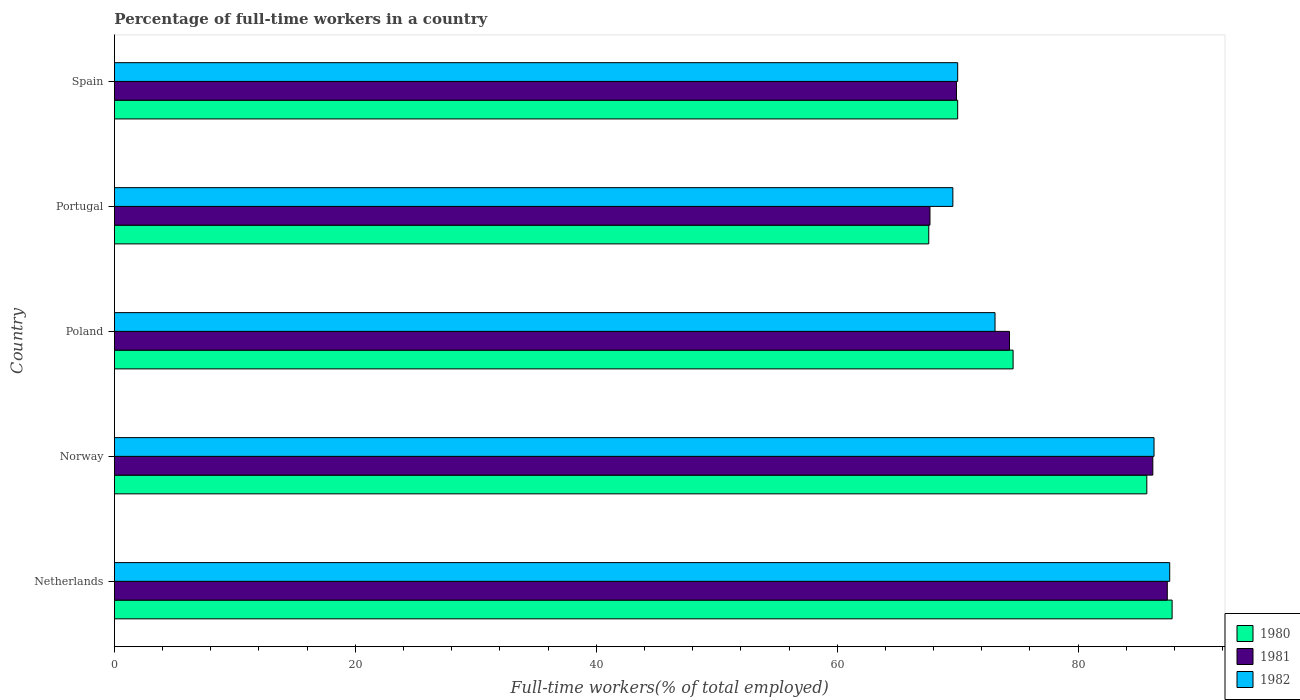Are the number of bars per tick equal to the number of legend labels?
Your answer should be very brief. Yes. Are the number of bars on each tick of the Y-axis equal?
Your answer should be compact. Yes. How many bars are there on the 3rd tick from the top?
Give a very brief answer. 3. What is the percentage of full-time workers in 1981 in Norway?
Make the answer very short. 86.2. Across all countries, what is the maximum percentage of full-time workers in 1981?
Your answer should be very brief. 87.4. Across all countries, what is the minimum percentage of full-time workers in 1980?
Your answer should be compact. 67.6. In which country was the percentage of full-time workers in 1982 maximum?
Provide a short and direct response. Netherlands. What is the total percentage of full-time workers in 1982 in the graph?
Your response must be concise. 386.6. What is the difference between the percentage of full-time workers in 1980 in Norway and that in Spain?
Provide a succinct answer. 15.7. What is the difference between the percentage of full-time workers in 1980 in Spain and the percentage of full-time workers in 1981 in Netherlands?
Keep it short and to the point. -17.4. What is the average percentage of full-time workers in 1980 per country?
Ensure brevity in your answer.  77.14. What is the difference between the percentage of full-time workers in 1981 and percentage of full-time workers in 1982 in Netherlands?
Ensure brevity in your answer.  -0.2. What is the ratio of the percentage of full-time workers in 1981 in Norway to that in Portugal?
Your answer should be very brief. 1.27. What is the difference between the highest and the second highest percentage of full-time workers in 1981?
Ensure brevity in your answer.  1.2. What is the difference between the highest and the lowest percentage of full-time workers in 1981?
Provide a succinct answer. 19.7. Is the sum of the percentage of full-time workers in 1982 in Norway and Portugal greater than the maximum percentage of full-time workers in 1981 across all countries?
Your answer should be very brief. Yes. How many bars are there?
Your answer should be compact. 15. Are all the bars in the graph horizontal?
Your answer should be very brief. Yes. Does the graph contain any zero values?
Offer a terse response. No. What is the title of the graph?
Keep it short and to the point. Percentage of full-time workers in a country. What is the label or title of the X-axis?
Your response must be concise. Full-time workers(% of total employed). What is the label or title of the Y-axis?
Ensure brevity in your answer.  Country. What is the Full-time workers(% of total employed) of 1980 in Netherlands?
Ensure brevity in your answer.  87.8. What is the Full-time workers(% of total employed) of 1981 in Netherlands?
Keep it short and to the point. 87.4. What is the Full-time workers(% of total employed) of 1982 in Netherlands?
Give a very brief answer. 87.6. What is the Full-time workers(% of total employed) of 1980 in Norway?
Keep it short and to the point. 85.7. What is the Full-time workers(% of total employed) in 1981 in Norway?
Provide a short and direct response. 86.2. What is the Full-time workers(% of total employed) in 1982 in Norway?
Your answer should be very brief. 86.3. What is the Full-time workers(% of total employed) in 1980 in Poland?
Your response must be concise. 74.6. What is the Full-time workers(% of total employed) of 1981 in Poland?
Provide a succinct answer. 74.3. What is the Full-time workers(% of total employed) in 1982 in Poland?
Provide a short and direct response. 73.1. What is the Full-time workers(% of total employed) of 1980 in Portugal?
Your answer should be very brief. 67.6. What is the Full-time workers(% of total employed) in 1981 in Portugal?
Your answer should be very brief. 67.7. What is the Full-time workers(% of total employed) of 1982 in Portugal?
Give a very brief answer. 69.6. What is the Full-time workers(% of total employed) of 1980 in Spain?
Ensure brevity in your answer.  70. What is the Full-time workers(% of total employed) in 1981 in Spain?
Provide a short and direct response. 69.9. Across all countries, what is the maximum Full-time workers(% of total employed) in 1980?
Provide a succinct answer. 87.8. Across all countries, what is the maximum Full-time workers(% of total employed) in 1981?
Your answer should be compact. 87.4. Across all countries, what is the maximum Full-time workers(% of total employed) of 1982?
Offer a very short reply. 87.6. Across all countries, what is the minimum Full-time workers(% of total employed) of 1980?
Your response must be concise. 67.6. Across all countries, what is the minimum Full-time workers(% of total employed) of 1981?
Ensure brevity in your answer.  67.7. Across all countries, what is the minimum Full-time workers(% of total employed) of 1982?
Offer a very short reply. 69.6. What is the total Full-time workers(% of total employed) of 1980 in the graph?
Make the answer very short. 385.7. What is the total Full-time workers(% of total employed) in 1981 in the graph?
Give a very brief answer. 385.5. What is the total Full-time workers(% of total employed) in 1982 in the graph?
Your answer should be compact. 386.6. What is the difference between the Full-time workers(% of total employed) of 1980 in Netherlands and that in Poland?
Make the answer very short. 13.2. What is the difference between the Full-time workers(% of total employed) of 1982 in Netherlands and that in Poland?
Your answer should be compact. 14.5. What is the difference between the Full-time workers(% of total employed) in 1980 in Netherlands and that in Portugal?
Ensure brevity in your answer.  20.2. What is the difference between the Full-time workers(% of total employed) in 1982 in Netherlands and that in Portugal?
Your answer should be compact. 18. What is the difference between the Full-time workers(% of total employed) in 1980 in Netherlands and that in Spain?
Give a very brief answer. 17.8. What is the difference between the Full-time workers(% of total employed) of 1981 in Netherlands and that in Spain?
Offer a terse response. 17.5. What is the difference between the Full-time workers(% of total employed) of 1982 in Netherlands and that in Spain?
Offer a terse response. 17.6. What is the difference between the Full-time workers(% of total employed) in 1980 in Norway and that in Poland?
Offer a terse response. 11.1. What is the difference between the Full-time workers(% of total employed) of 1980 in Norway and that in Portugal?
Ensure brevity in your answer.  18.1. What is the difference between the Full-time workers(% of total employed) in 1981 in Norway and that in Portugal?
Your answer should be very brief. 18.5. What is the difference between the Full-time workers(% of total employed) of 1982 in Norway and that in Portugal?
Ensure brevity in your answer.  16.7. What is the difference between the Full-time workers(% of total employed) in 1980 in Norway and that in Spain?
Ensure brevity in your answer.  15.7. What is the difference between the Full-time workers(% of total employed) of 1981 in Norway and that in Spain?
Your response must be concise. 16.3. What is the difference between the Full-time workers(% of total employed) in 1982 in Norway and that in Spain?
Your answer should be compact. 16.3. What is the difference between the Full-time workers(% of total employed) in 1982 in Poland and that in Portugal?
Your response must be concise. 3.5. What is the difference between the Full-time workers(% of total employed) of 1981 in Poland and that in Spain?
Ensure brevity in your answer.  4.4. What is the difference between the Full-time workers(% of total employed) of 1982 in Poland and that in Spain?
Your answer should be compact. 3.1. What is the difference between the Full-time workers(% of total employed) in 1980 in Portugal and that in Spain?
Provide a short and direct response. -2.4. What is the difference between the Full-time workers(% of total employed) in 1981 in Portugal and that in Spain?
Keep it short and to the point. -2.2. What is the difference between the Full-time workers(% of total employed) in 1982 in Portugal and that in Spain?
Give a very brief answer. -0.4. What is the difference between the Full-time workers(% of total employed) of 1980 in Netherlands and the Full-time workers(% of total employed) of 1981 in Norway?
Ensure brevity in your answer.  1.6. What is the difference between the Full-time workers(% of total employed) of 1981 in Netherlands and the Full-time workers(% of total employed) of 1982 in Norway?
Ensure brevity in your answer.  1.1. What is the difference between the Full-time workers(% of total employed) of 1980 in Netherlands and the Full-time workers(% of total employed) of 1981 in Poland?
Provide a succinct answer. 13.5. What is the difference between the Full-time workers(% of total employed) of 1980 in Netherlands and the Full-time workers(% of total employed) of 1982 in Poland?
Keep it short and to the point. 14.7. What is the difference between the Full-time workers(% of total employed) of 1981 in Netherlands and the Full-time workers(% of total employed) of 1982 in Poland?
Your answer should be very brief. 14.3. What is the difference between the Full-time workers(% of total employed) in 1980 in Netherlands and the Full-time workers(% of total employed) in 1981 in Portugal?
Offer a terse response. 20.1. What is the difference between the Full-time workers(% of total employed) in 1980 in Netherlands and the Full-time workers(% of total employed) in 1982 in Portugal?
Your answer should be very brief. 18.2. What is the difference between the Full-time workers(% of total employed) of 1980 in Netherlands and the Full-time workers(% of total employed) of 1982 in Spain?
Keep it short and to the point. 17.8. What is the difference between the Full-time workers(% of total employed) of 1981 in Netherlands and the Full-time workers(% of total employed) of 1982 in Spain?
Your response must be concise. 17.4. What is the difference between the Full-time workers(% of total employed) in 1980 in Norway and the Full-time workers(% of total employed) in 1981 in Poland?
Provide a short and direct response. 11.4. What is the difference between the Full-time workers(% of total employed) in 1980 in Norway and the Full-time workers(% of total employed) in 1982 in Poland?
Make the answer very short. 12.6. What is the difference between the Full-time workers(% of total employed) of 1981 in Norway and the Full-time workers(% of total employed) of 1982 in Poland?
Offer a terse response. 13.1. What is the difference between the Full-time workers(% of total employed) of 1980 in Norway and the Full-time workers(% of total employed) of 1981 in Portugal?
Offer a terse response. 18. What is the difference between the Full-time workers(% of total employed) of 1980 in Norway and the Full-time workers(% of total employed) of 1981 in Spain?
Give a very brief answer. 15.8. What is the difference between the Full-time workers(% of total employed) in 1980 in Norway and the Full-time workers(% of total employed) in 1982 in Spain?
Provide a succinct answer. 15.7. What is the difference between the Full-time workers(% of total employed) of 1980 in Poland and the Full-time workers(% of total employed) of 1982 in Portugal?
Provide a succinct answer. 5. What is the difference between the Full-time workers(% of total employed) of 1980 in Poland and the Full-time workers(% of total employed) of 1982 in Spain?
Your answer should be very brief. 4.6. What is the difference between the Full-time workers(% of total employed) of 1981 in Poland and the Full-time workers(% of total employed) of 1982 in Spain?
Offer a very short reply. 4.3. What is the difference between the Full-time workers(% of total employed) in 1981 in Portugal and the Full-time workers(% of total employed) in 1982 in Spain?
Make the answer very short. -2.3. What is the average Full-time workers(% of total employed) of 1980 per country?
Offer a terse response. 77.14. What is the average Full-time workers(% of total employed) of 1981 per country?
Your response must be concise. 77.1. What is the average Full-time workers(% of total employed) in 1982 per country?
Give a very brief answer. 77.32. What is the difference between the Full-time workers(% of total employed) of 1980 and Full-time workers(% of total employed) of 1982 in Netherlands?
Keep it short and to the point. 0.2. What is the difference between the Full-time workers(% of total employed) of 1981 and Full-time workers(% of total employed) of 1982 in Poland?
Give a very brief answer. 1.2. What is the difference between the Full-time workers(% of total employed) in 1980 and Full-time workers(% of total employed) in 1981 in Portugal?
Give a very brief answer. -0.1. What is the difference between the Full-time workers(% of total employed) of 1980 and Full-time workers(% of total employed) of 1982 in Portugal?
Provide a succinct answer. -2. What is the difference between the Full-time workers(% of total employed) in 1980 and Full-time workers(% of total employed) in 1982 in Spain?
Provide a short and direct response. 0. What is the ratio of the Full-time workers(% of total employed) of 1980 in Netherlands to that in Norway?
Your answer should be compact. 1.02. What is the ratio of the Full-time workers(% of total employed) of 1981 in Netherlands to that in Norway?
Make the answer very short. 1.01. What is the ratio of the Full-time workers(% of total employed) of 1982 in Netherlands to that in Norway?
Your answer should be very brief. 1.02. What is the ratio of the Full-time workers(% of total employed) of 1980 in Netherlands to that in Poland?
Provide a succinct answer. 1.18. What is the ratio of the Full-time workers(% of total employed) of 1981 in Netherlands to that in Poland?
Your response must be concise. 1.18. What is the ratio of the Full-time workers(% of total employed) in 1982 in Netherlands to that in Poland?
Keep it short and to the point. 1.2. What is the ratio of the Full-time workers(% of total employed) in 1980 in Netherlands to that in Portugal?
Keep it short and to the point. 1.3. What is the ratio of the Full-time workers(% of total employed) of 1981 in Netherlands to that in Portugal?
Offer a very short reply. 1.29. What is the ratio of the Full-time workers(% of total employed) in 1982 in Netherlands to that in Portugal?
Offer a very short reply. 1.26. What is the ratio of the Full-time workers(% of total employed) of 1980 in Netherlands to that in Spain?
Ensure brevity in your answer.  1.25. What is the ratio of the Full-time workers(% of total employed) of 1981 in Netherlands to that in Spain?
Give a very brief answer. 1.25. What is the ratio of the Full-time workers(% of total employed) in 1982 in Netherlands to that in Spain?
Your response must be concise. 1.25. What is the ratio of the Full-time workers(% of total employed) in 1980 in Norway to that in Poland?
Your answer should be compact. 1.15. What is the ratio of the Full-time workers(% of total employed) in 1981 in Norway to that in Poland?
Make the answer very short. 1.16. What is the ratio of the Full-time workers(% of total employed) of 1982 in Norway to that in Poland?
Your response must be concise. 1.18. What is the ratio of the Full-time workers(% of total employed) of 1980 in Norway to that in Portugal?
Make the answer very short. 1.27. What is the ratio of the Full-time workers(% of total employed) of 1981 in Norway to that in Portugal?
Provide a short and direct response. 1.27. What is the ratio of the Full-time workers(% of total employed) of 1982 in Norway to that in Portugal?
Keep it short and to the point. 1.24. What is the ratio of the Full-time workers(% of total employed) in 1980 in Norway to that in Spain?
Provide a short and direct response. 1.22. What is the ratio of the Full-time workers(% of total employed) of 1981 in Norway to that in Spain?
Provide a short and direct response. 1.23. What is the ratio of the Full-time workers(% of total employed) in 1982 in Norway to that in Spain?
Ensure brevity in your answer.  1.23. What is the ratio of the Full-time workers(% of total employed) of 1980 in Poland to that in Portugal?
Make the answer very short. 1.1. What is the ratio of the Full-time workers(% of total employed) in 1981 in Poland to that in Portugal?
Offer a very short reply. 1.1. What is the ratio of the Full-time workers(% of total employed) of 1982 in Poland to that in Portugal?
Provide a succinct answer. 1.05. What is the ratio of the Full-time workers(% of total employed) of 1980 in Poland to that in Spain?
Your response must be concise. 1.07. What is the ratio of the Full-time workers(% of total employed) in 1981 in Poland to that in Spain?
Make the answer very short. 1.06. What is the ratio of the Full-time workers(% of total employed) in 1982 in Poland to that in Spain?
Make the answer very short. 1.04. What is the ratio of the Full-time workers(% of total employed) of 1980 in Portugal to that in Spain?
Provide a short and direct response. 0.97. What is the ratio of the Full-time workers(% of total employed) of 1981 in Portugal to that in Spain?
Your response must be concise. 0.97. What is the difference between the highest and the second highest Full-time workers(% of total employed) of 1980?
Your answer should be compact. 2.1. What is the difference between the highest and the lowest Full-time workers(% of total employed) of 1980?
Provide a short and direct response. 20.2. What is the difference between the highest and the lowest Full-time workers(% of total employed) of 1981?
Provide a short and direct response. 19.7. What is the difference between the highest and the lowest Full-time workers(% of total employed) in 1982?
Provide a succinct answer. 18. 